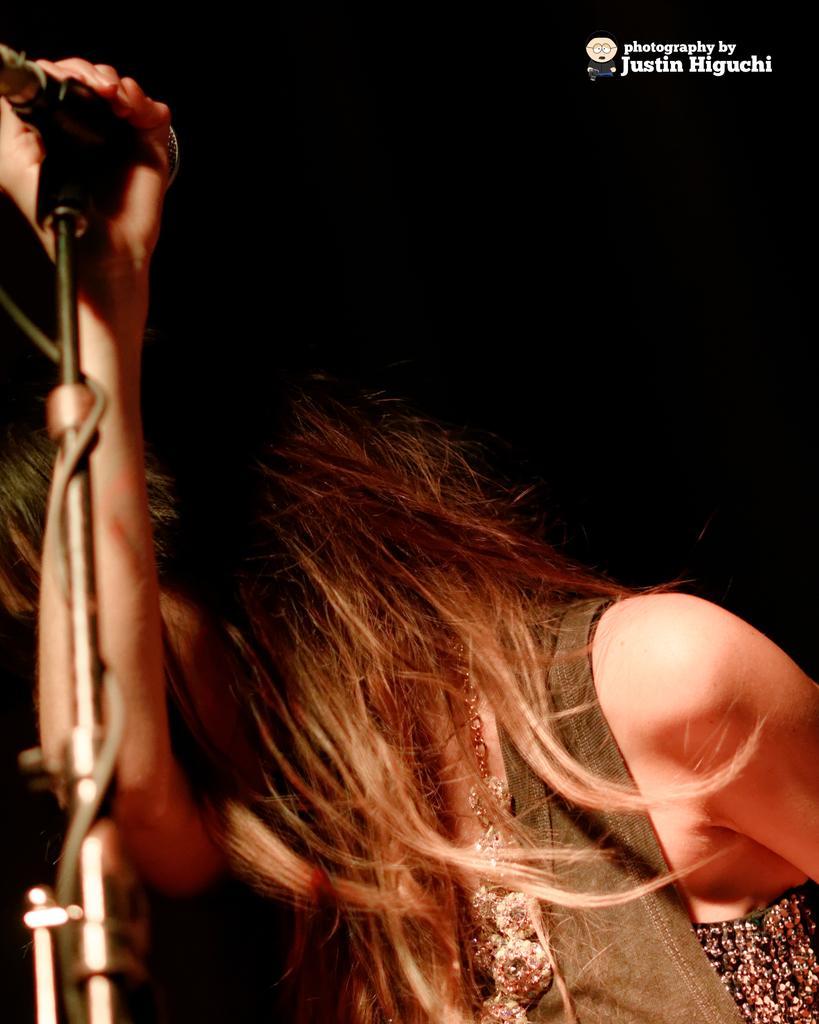Can you describe this image briefly? In the center we can see one woman standing and holding microphone and she is wearing jacket. 